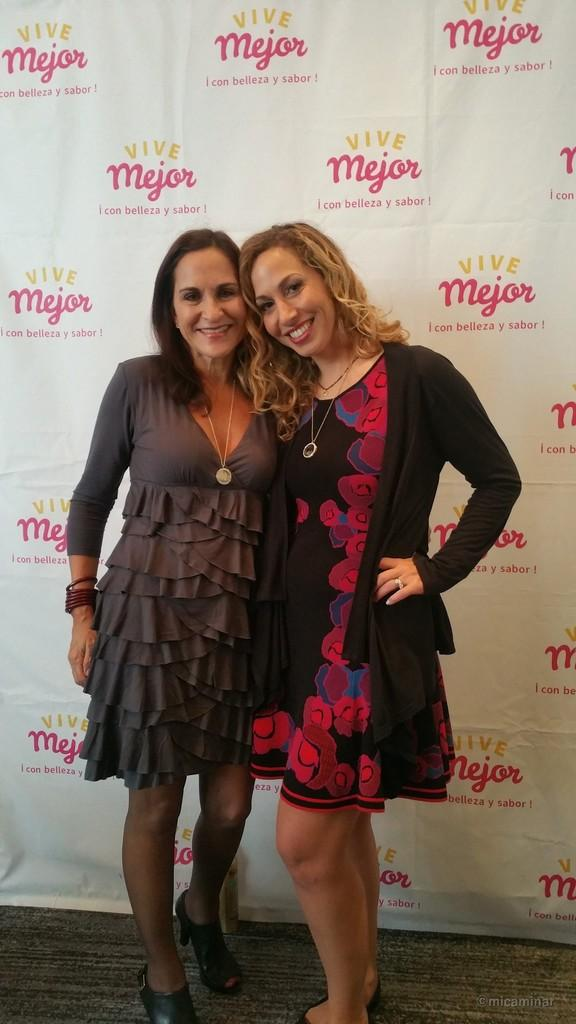How many women are in the image? There are two women in the image. What are the women doing in the image? The women are standing and smiling. Is there any text or markings on the image? Yes, there is a watermark in the image, some text in the bottom right, and some text visible on a white object in the background. What type of cheese is being pointed at in the image? There is no cheese present in the image, nor is anyone pointing at anything. 